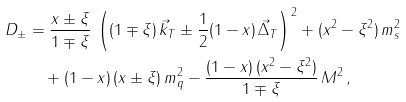Convert formula to latex. <formula><loc_0><loc_0><loc_500><loc_500>D _ { \pm } & = \frac { x \pm \xi } { 1 \mp \xi } \, \left ( ( 1 \mp \xi ) \, \vec { k } _ { T } \pm \frac { 1 } { 2 } ( 1 - x ) \, \vec { \Delta } _ { T } \right ) ^ { 2 } + ( x ^ { 2 } - \xi ^ { 2 } ) \, m _ { s } ^ { 2 } \\ & \quad + ( 1 - x ) \, ( x \pm \xi ) \, m _ { q } ^ { 2 } - \frac { ( 1 - x ) \, ( x ^ { 2 } - \xi ^ { 2 } ) } { 1 \mp \xi } \, M ^ { 2 } \, ,</formula> 